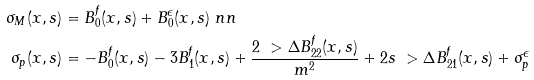<formula> <loc_0><loc_0><loc_500><loc_500>\sigma _ { M } ( x , s ) & = B _ { 0 } ^ { f } ( x , s ) + B _ { 0 } ^ { \epsilon } ( x , s ) \ n n \\ \sigma _ { p } ( x , s ) & = - B _ { 0 } ^ { f } ( x , s ) - 3 B _ { 1 } ^ { f } ( x , s ) + \frac { 2 \ > \Delta B _ { 2 2 } ^ { f } ( x , s ) } { m ^ { 2 } } + 2 s \ > \Delta B _ { 2 1 } ^ { f } ( x , s ) + \sigma _ { p } ^ { \epsilon }</formula> 